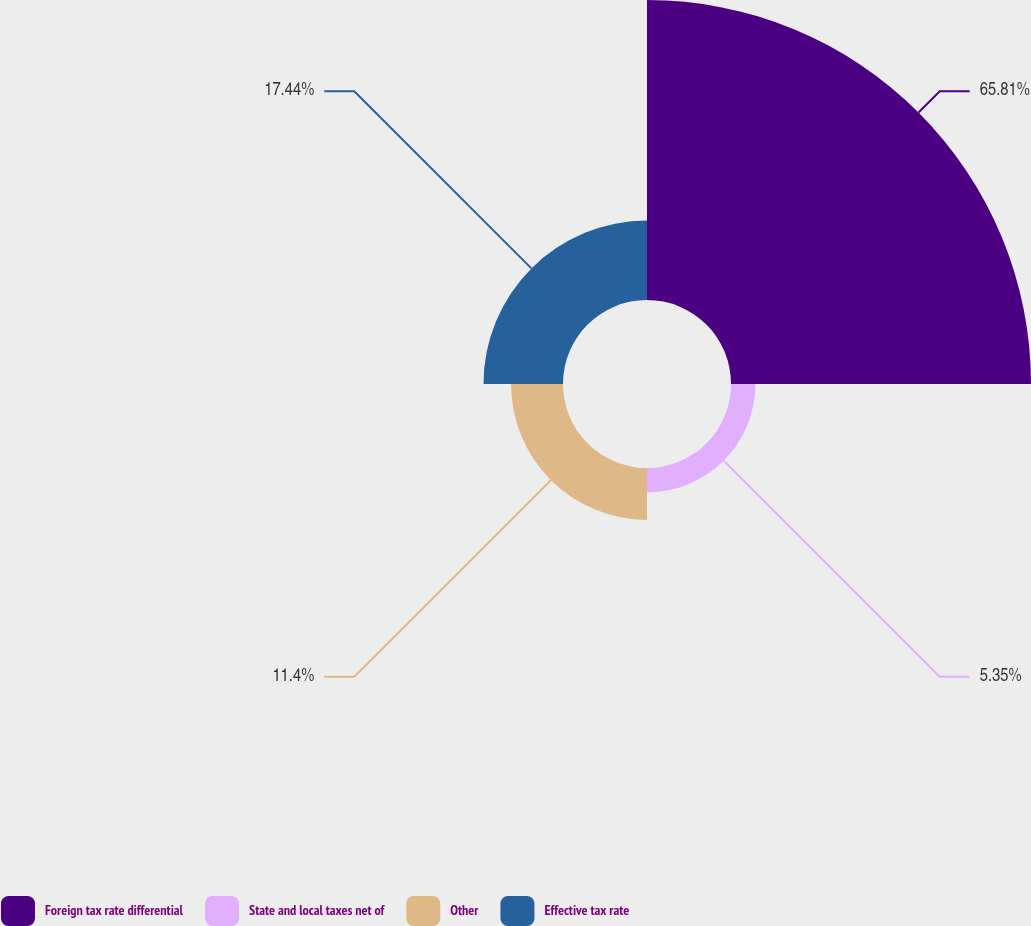Convert chart. <chart><loc_0><loc_0><loc_500><loc_500><pie_chart><fcel>Foreign tax rate differential<fcel>State and local taxes net of<fcel>Other<fcel>Effective tax rate<nl><fcel>65.81%<fcel>5.35%<fcel>11.4%<fcel>17.44%<nl></chart> 